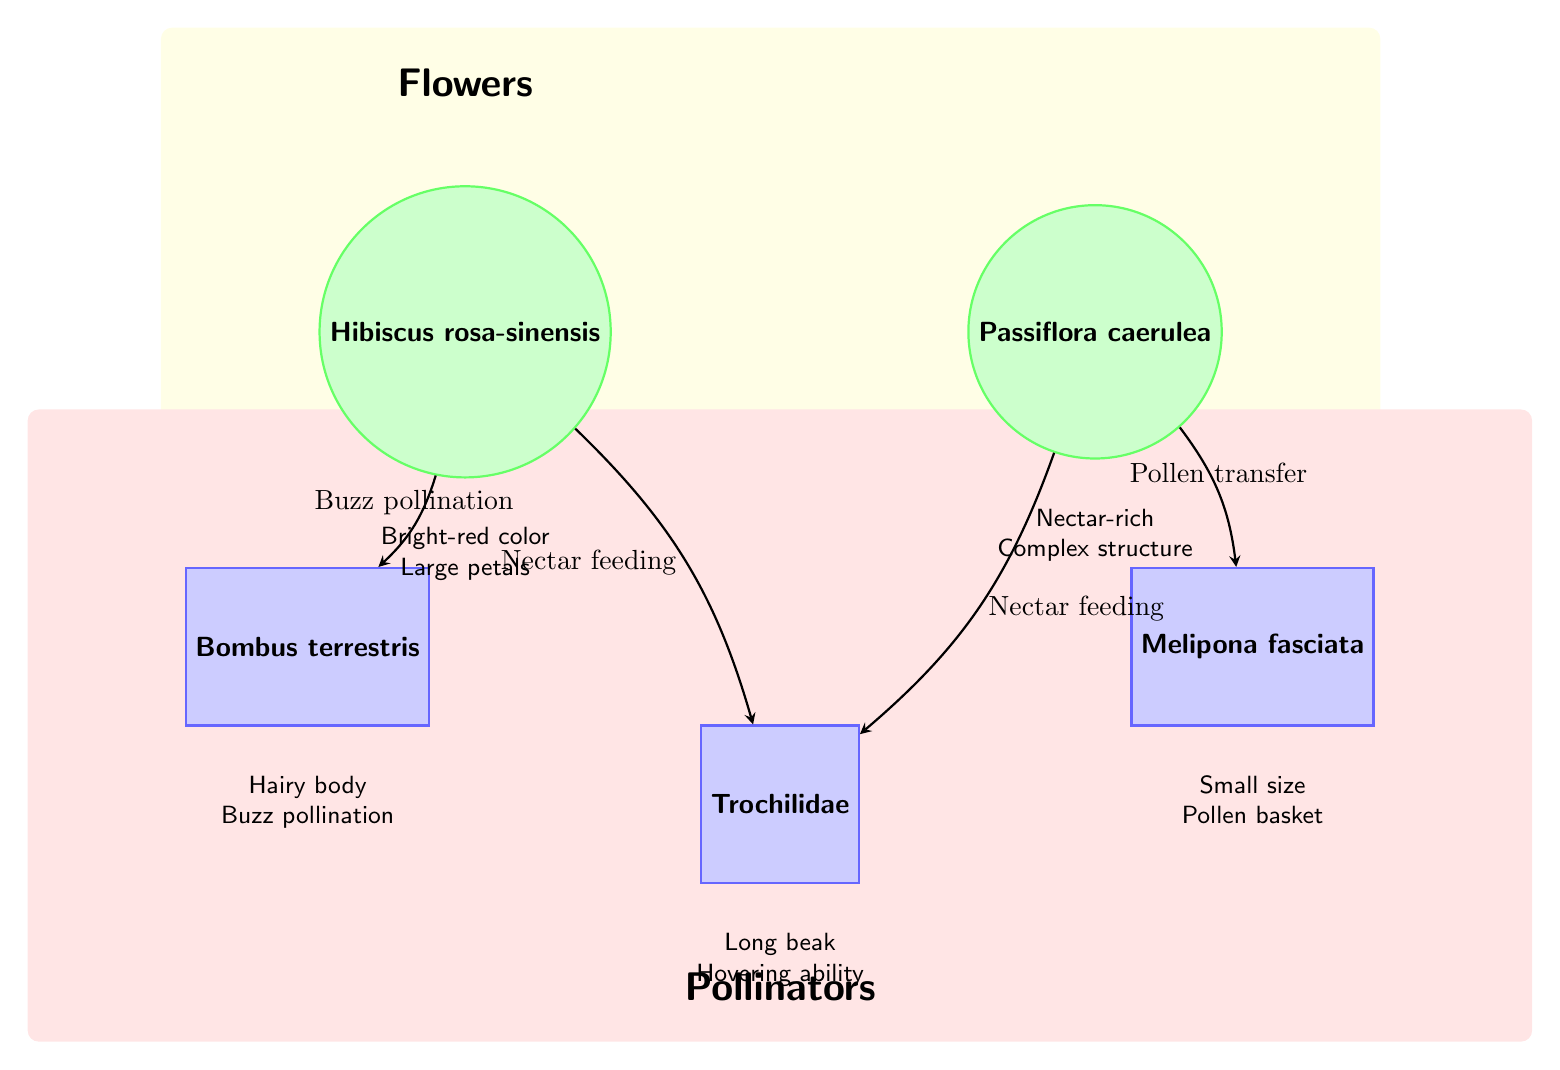What are the two flower species depicted? The diagram shows two flower species: Hibiscus rosa-sinensis and Passiflora caerulea, which can be directly identified from their labels in the nodes representing flowers.
Answer: Hibiscus rosa-sinensis, Passiflora caerulea How many pollinator species are shown in the diagram? The diagram contains three distinct pollinator species: Bombus terrestris, Melipona fasciata, and Trochilidae, all of which are represented in the nodes designated for pollinators.
Answer: 3 What type of interaction occurs between Hibiscus rosa-sinensis and Bombus terrestris? The edge connecting Hibiscus rosa-sinensis to Bombus terrestris is labeled "Buzz pollination," indicating the specific type of interaction they have.
Answer: Buzz pollination Which flower species has a nectar-rich attribute? The description below the node for Passiflora caerulea states "Nectar-rich," indicating that this flower species is known for its nectar.
Answer: Passiflora caerulea What feature is associated with the pollinator species Trochilidae? Trochilidae is described by the label "Long beak" below its respective node, indicating this anatomical feature is a characteristic of this particular pollinator.
Answer: Long beak Which pollinator specializes in pollen transfer from the flower Passiflora caerulea? Melipona fasciata is the pollinator specifically linked to Passiflora caerulea through the edge labeled "Pollen transfer," showing its role in this interaction.
Answer: Melipona fasciata What is the common feed mechanism for both pollinator species Trochilidae and Bombus terrestris? Both pollinator species are linked to nectar feeding in the diagram, indicated by their respective edges connected to the flowers.
Answer: Nectar feeding Which flower is characterized by bright-red color and large petals? The node for Hibiscus rosa-sinensis has the description "Bright-red color" and "Large petals" below it, identifying these characteristics of that flower species.
Answer: Hibiscus rosa-sinensis 